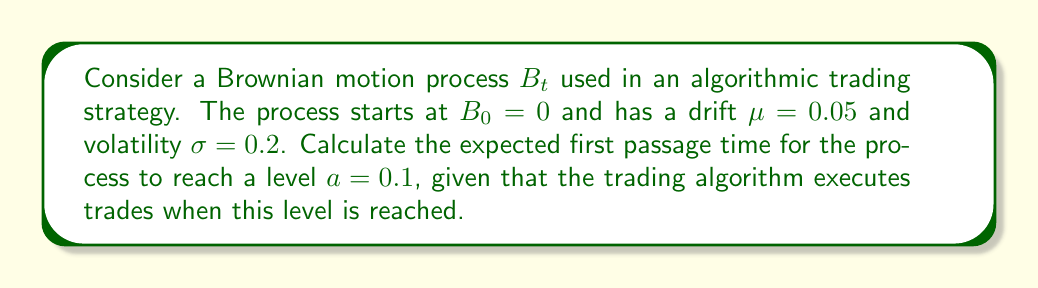What is the answer to this math problem? To solve this problem, we'll use the formula for the expected first passage time of a Brownian motion with drift. The steps are as follows:

1) The expected first passage time $T_a$ for a Brownian motion with drift $\mu$ and volatility $\sigma$ to reach a level $a$ is given by:

   $$E[T_a] = \frac{a}{\mu}$$

   This formula assumes that $\mu > 0$ and $a > 0$, which is true in our case.

2) We are given:
   $a = 0.1$
   $\mu = 0.05$
   $\sigma = 0.2$ (note that $\sigma$ is not used in this calculation)

3) Substituting these values into the formula:

   $$E[T_a] = \frac{0.1}{0.05}$$

4) Simplifying:

   $$E[T_a] = 2$$

5) Interpret the result: The expected first passage time is 2 time units. In the context of algorithmic trading, if the time unit is days, this means the trading algorithm is expected to execute a trade after 2 days on average.
Answer: 2 time units 